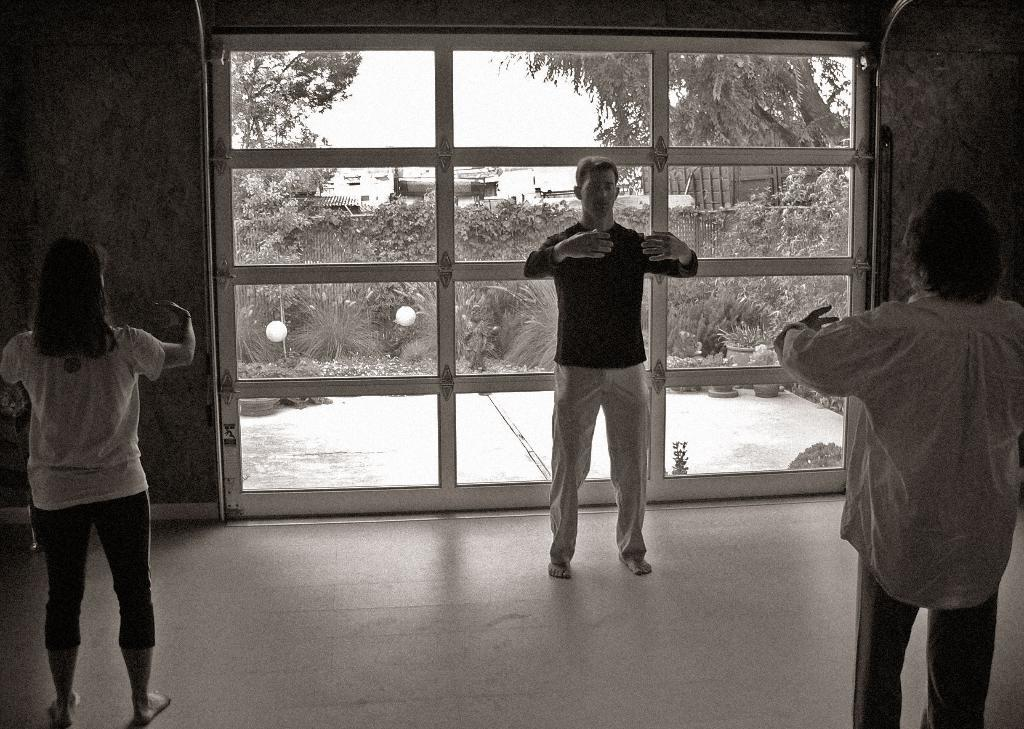What is happening in the image? There are people standing in the image. Where are the people standing? The people are standing on a floor. What can be seen in the background of the image? There is a wall in the background of the image. What is a feature of the wall? There is a glass door in the wall. What can be seen through the glass door? Plants, trees, and the sky are visible through the glass door. Can you tell me how many goldfish are swimming in the glass door? There are no goldfish present in the image; the glass door shows plants, trees, and the sky. Is there a baby crawling on the floor in the image? There is no baby present in the image; it only shows people standing on the floor. 